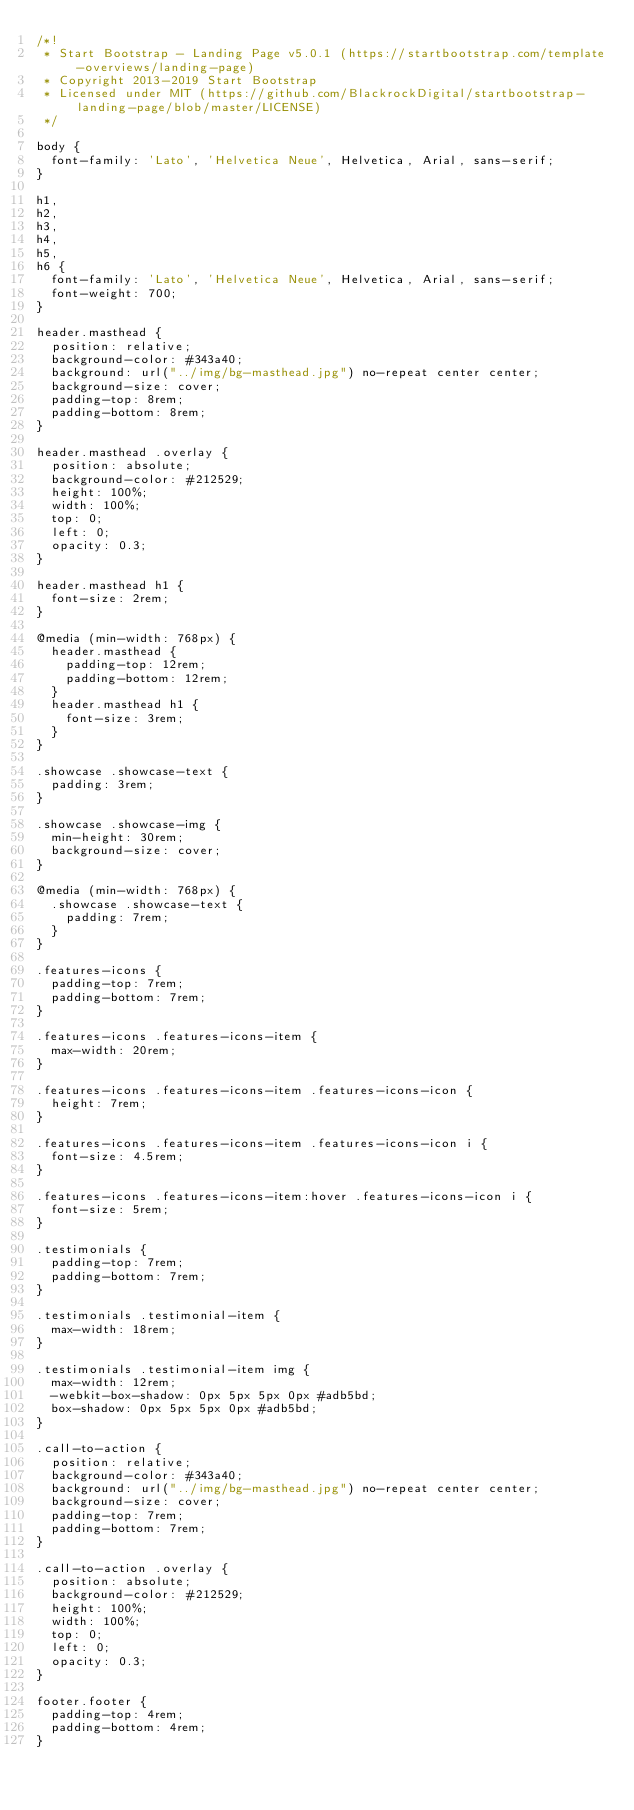<code> <loc_0><loc_0><loc_500><loc_500><_CSS_>/*!
 * Start Bootstrap - Landing Page v5.0.1 (https://startbootstrap.com/template-overviews/landing-page)
 * Copyright 2013-2019 Start Bootstrap
 * Licensed under MIT (https://github.com/BlackrockDigital/startbootstrap-landing-page/blob/master/LICENSE)
 */

body {
  font-family: 'Lato', 'Helvetica Neue', Helvetica, Arial, sans-serif;
}

h1,
h2,
h3,
h4,
h5,
h6 {
  font-family: 'Lato', 'Helvetica Neue', Helvetica, Arial, sans-serif;
  font-weight: 700;
}

header.masthead {
  position: relative;
  background-color: #343a40;
  background: url("../img/bg-masthead.jpg") no-repeat center center;
  background-size: cover;
  padding-top: 8rem;
  padding-bottom: 8rem;
}

header.masthead .overlay {
  position: absolute;
  background-color: #212529;
  height: 100%;
  width: 100%;
  top: 0;
  left: 0;
  opacity: 0.3;
}

header.masthead h1 {
  font-size: 2rem;
}

@media (min-width: 768px) {
  header.masthead {
    padding-top: 12rem;
    padding-bottom: 12rem;
  }
  header.masthead h1 {
    font-size: 3rem;
  }
}

.showcase .showcase-text {
  padding: 3rem;
}

.showcase .showcase-img {
  min-height: 30rem;
  background-size: cover;
}

@media (min-width: 768px) {
  .showcase .showcase-text {
    padding: 7rem;
  }
}

.features-icons {
  padding-top: 7rem;
  padding-bottom: 7rem;
}

.features-icons .features-icons-item {
  max-width: 20rem;
}

.features-icons .features-icons-item .features-icons-icon {
  height: 7rem;
}

.features-icons .features-icons-item .features-icons-icon i {
  font-size: 4.5rem;
}

.features-icons .features-icons-item:hover .features-icons-icon i {
  font-size: 5rem;
}

.testimonials {
  padding-top: 7rem;
  padding-bottom: 7rem;
}

.testimonials .testimonial-item {
  max-width: 18rem;
}

.testimonials .testimonial-item img {
  max-width: 12rem;
  -webkit-box-shadow: 0px 5px 5px 0px #adb5bd;
  box-shadow: 0px 5px 5px 0px #adb5bd;
}

.call-to-action {
  position: relative;
  background-color: #343a40;
  background: url("../img/bg-masthead.jpg") no-repeat center center;
  background-size: cover;
  padding-top: 7rem;
  padding-bottom: 7rem;
}

.call-to-action .overlay {
  position: absolute;
  background-color: #212529;
  height: 100%;
  width: 100%;
  top: 0;
  left: 0;
  opacity: 0.3;
}

footer.footer {
  padding-top: 4rem;
  padding-bottom: 4rem;
}
</code> 